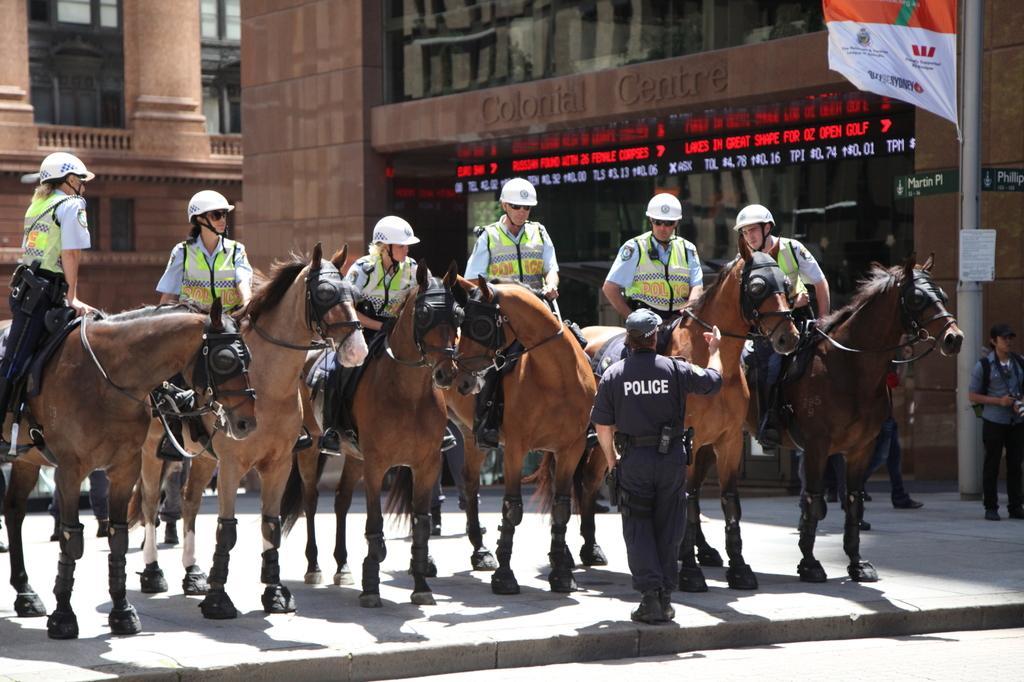Describe this image in one or two sentences. In this image we can see a group of horses on the ground, they are in brown color, there are persons sitting on it, they are wearing a jacket, there is a building, there is a glass door, there is a pole, there is a flag, there are persons standing on the ground. 